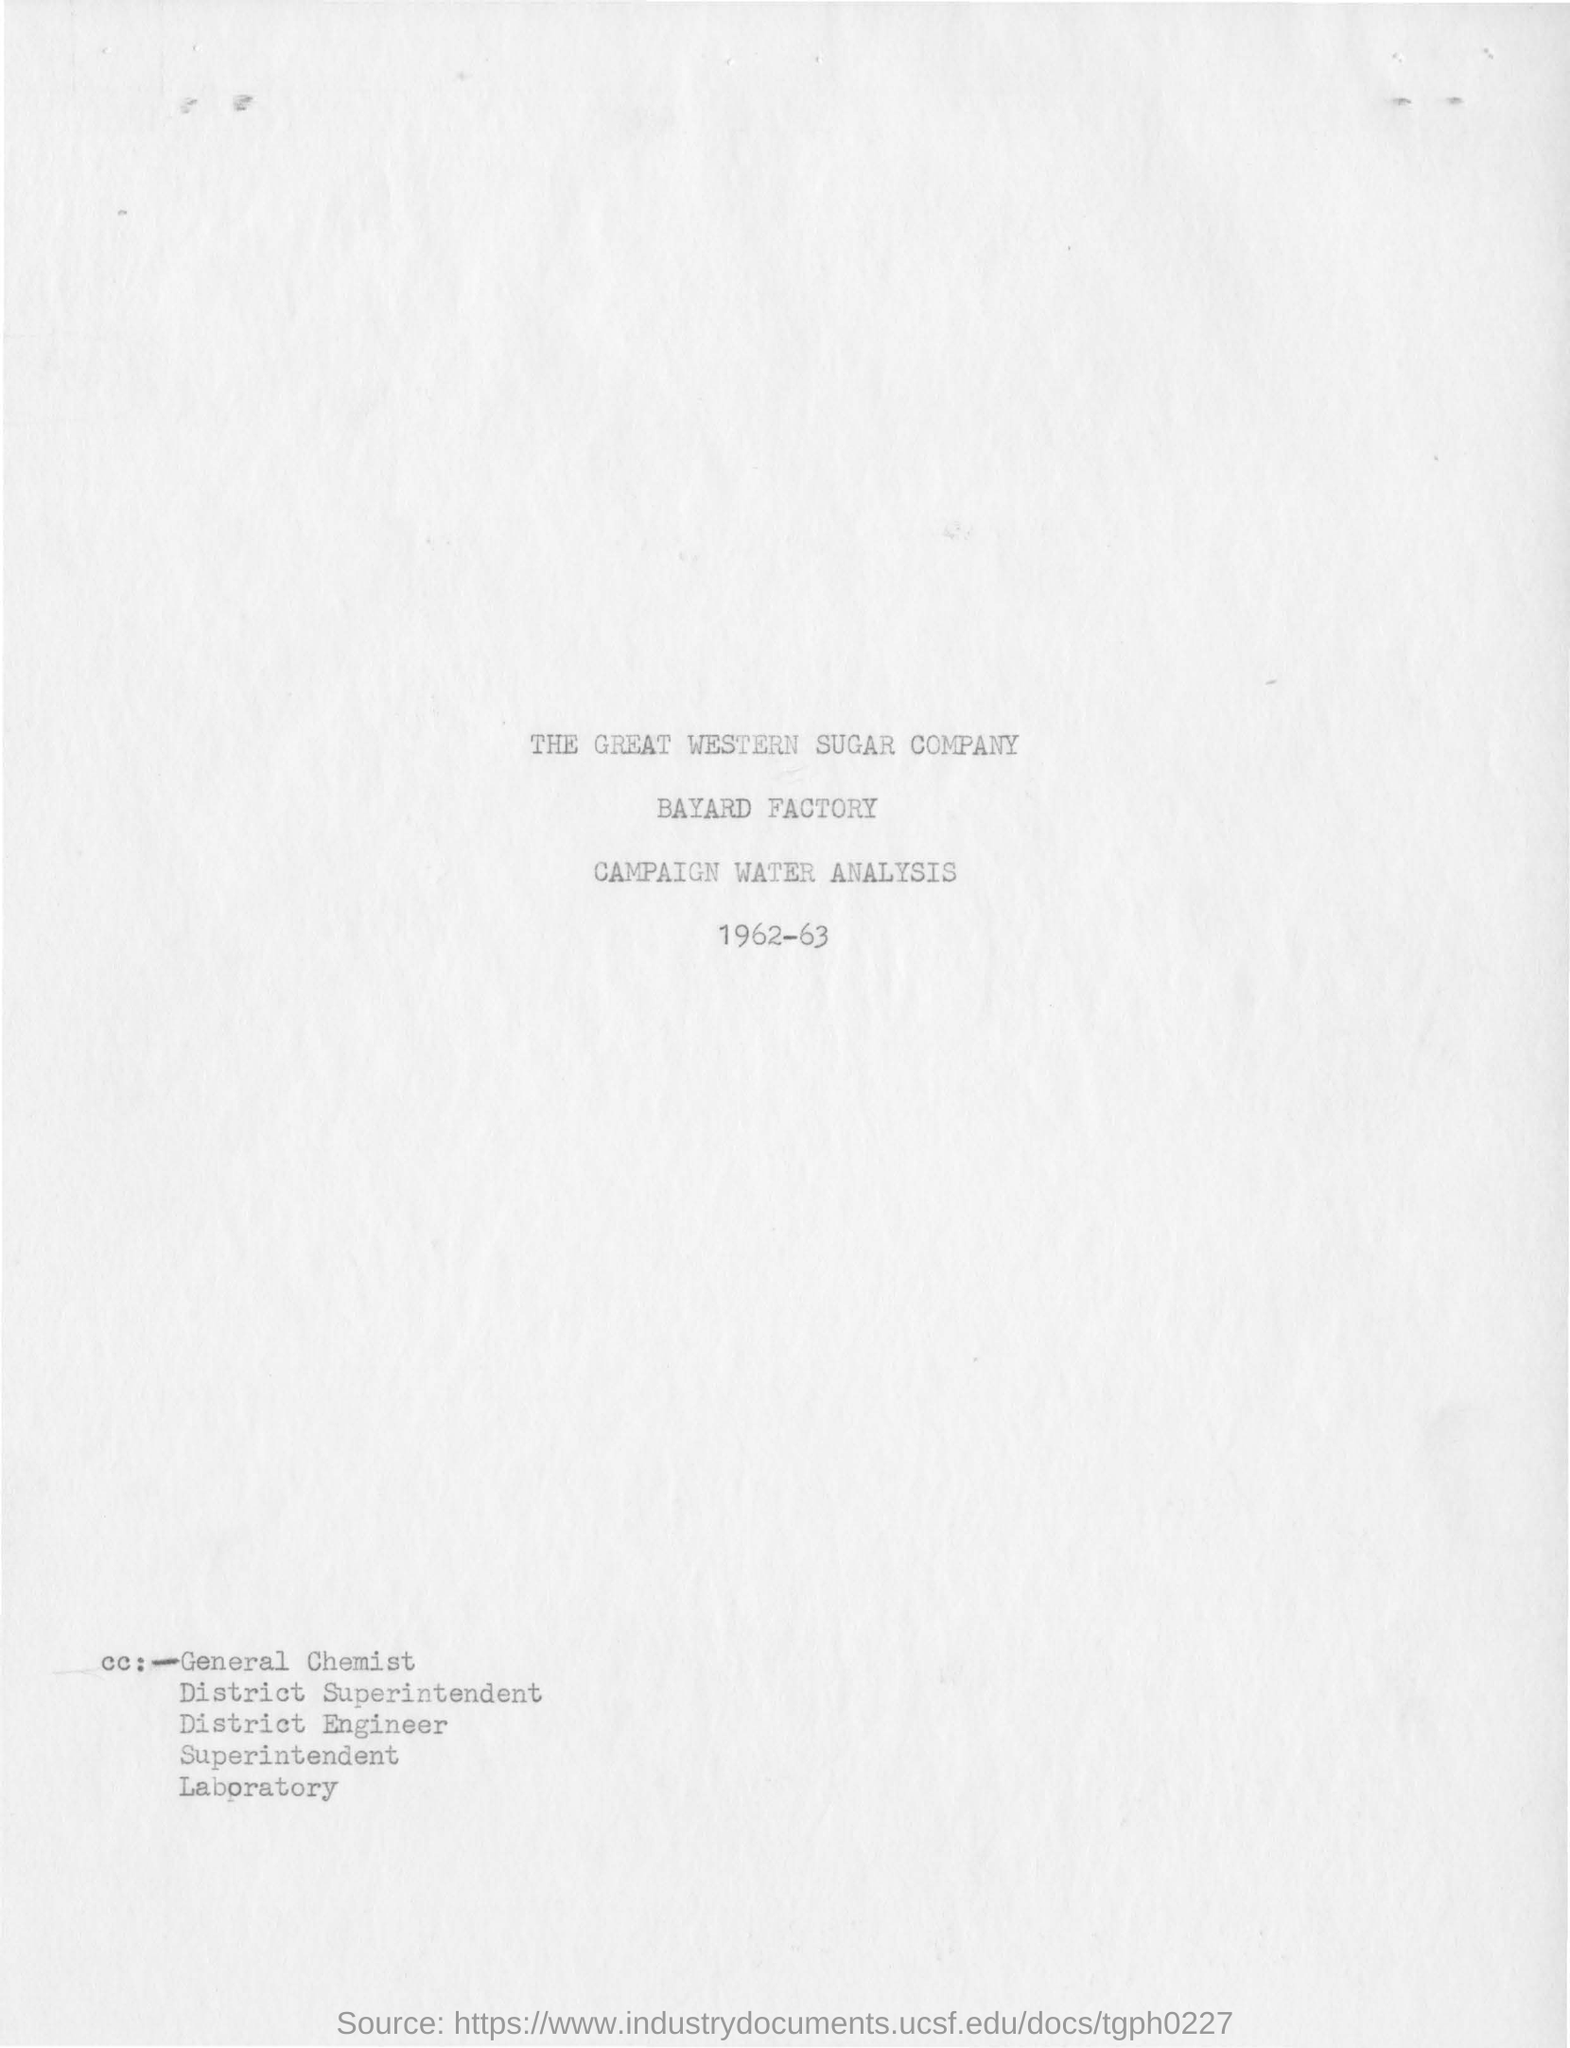Which factory is mentioned in the report?
Offer a terse response. Bayard Factory. For which year is the analysis report?
Provide a short and direct response. 1962-63. 